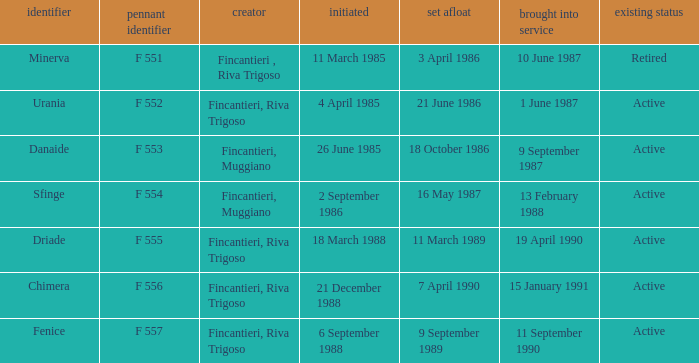Which launch date involved the Driade? 11 March 1989. 